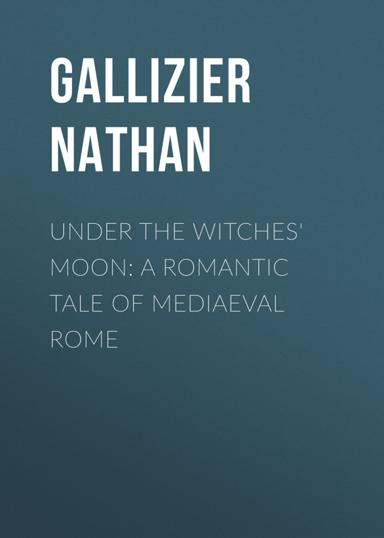What is the setting of "Under the Witches' Moon"? The novel "Under the Witches' Moon" is set in the intriguing and historically rich setting of medieval Rome. This period, characterized by dramatic societal shifts and the ornate architecture of the time, provides a vibrant backdrop to the romantic and mystical storyline of the book. 